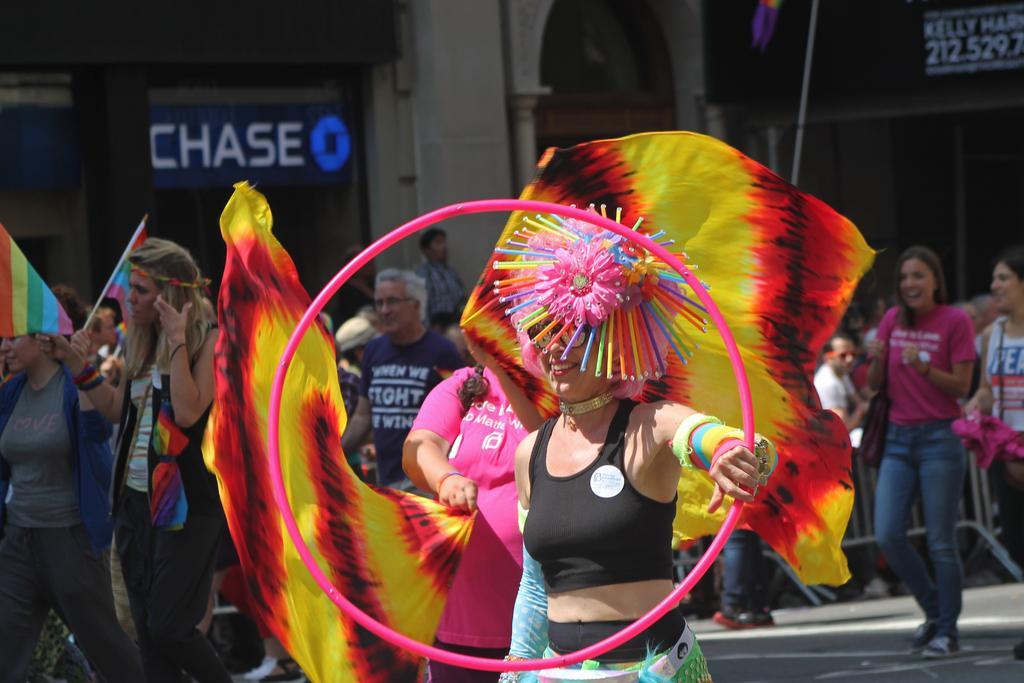Describe this image in one or two sentences. In this image there are some persons standing as we can see in the bottom of this image. There is a wall in the background. The person standing in the bottom of this image is holding an object. 